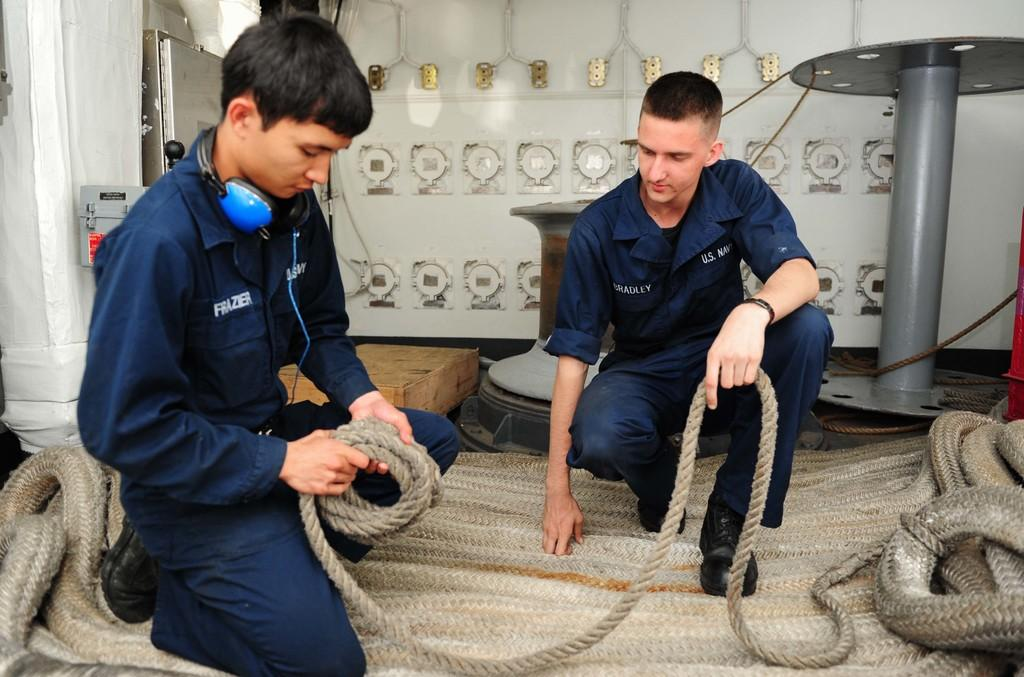How many people are in the image? There are two men in the image. What position are the men in? The men are in a squat position on a rope. What are the men holding in their hands? The men are holding a rope in their hands. What can be seen in the background of the image? There is a wall and metal items in the background of the image. What is present on the left side of the image? There are metal objects on the left side of the image. What flavor of sock is the man wearing on his right foot? There is no sock visible in the image, and therefore no flavor can be determined. 